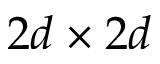Convert formula to latex. <formula><loc_0><loc_0><loc_500><loc_500>2 d \times 2 d</formula> 